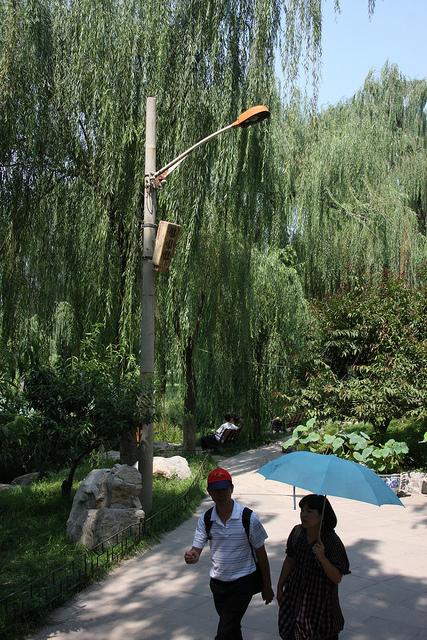What color is the umbrella?
Keep it brief. Blue. What color is the man's Hat?
Quick response, please. Red. Why is the woman using an umbrella?
Short answer required. Yes. 